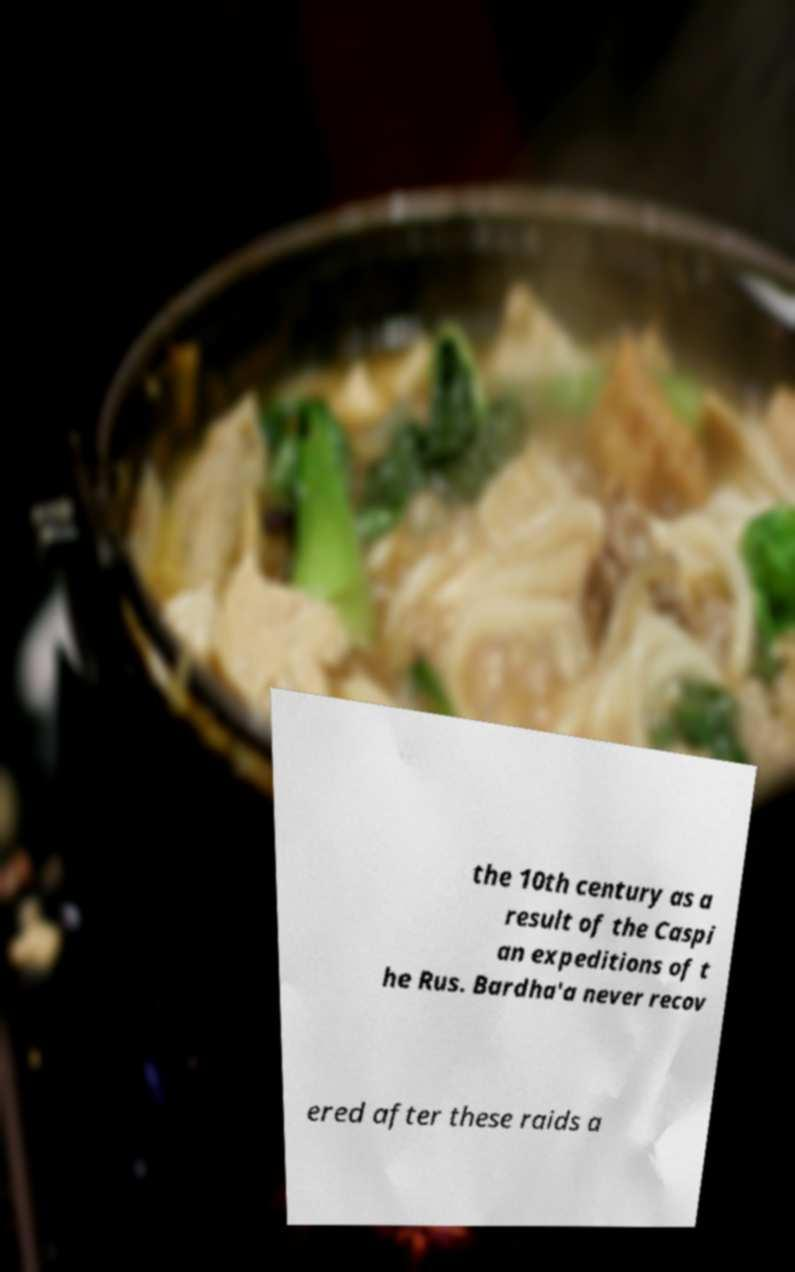Could you assist in decoding the text presented in this image and type it out clearly? the 10th century as a result of the Caspi an expeditions of t he Rus. Bardha'a never recov ered after these raids a 